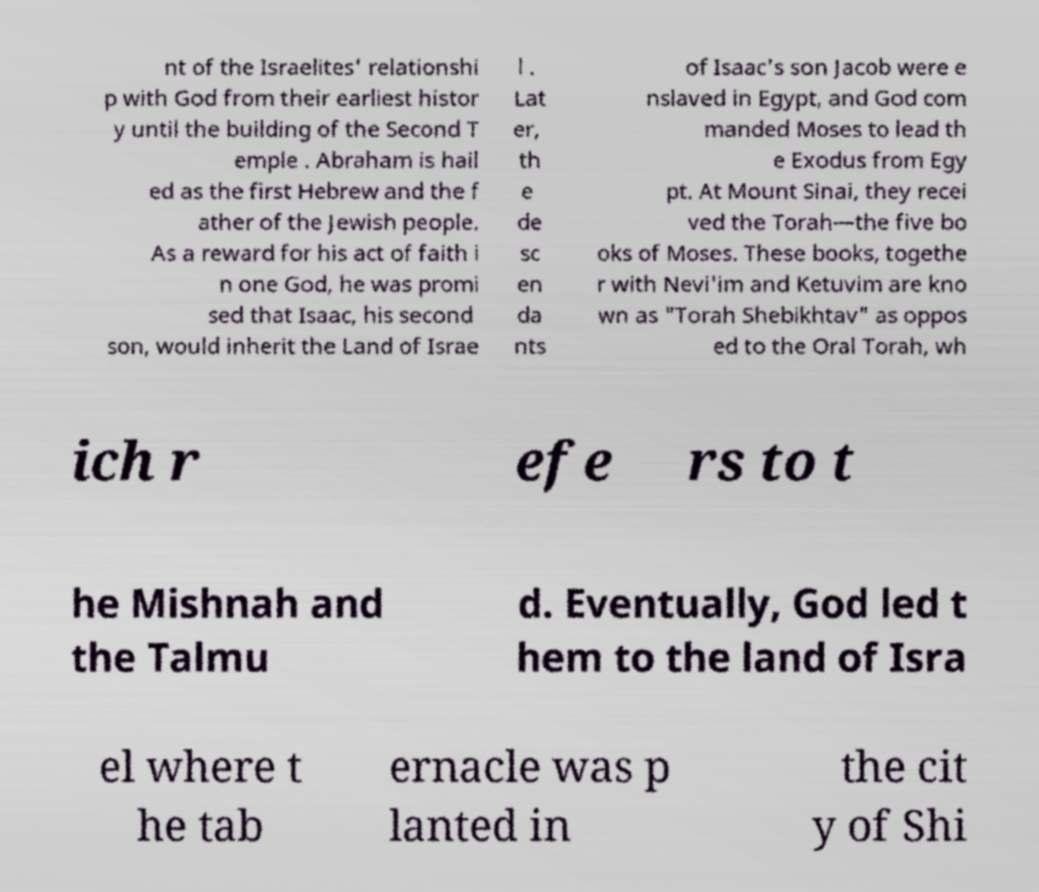There's text embedded in this image that I need extracted. Can you transcribe it verbatim? nt of the Israelites' relationshi p with God from their earliest histor y until the building of the Second T emple . Abraham is hail ed as the first Hebrew and the f ather of the Jewish people. As a reward for his act of faith i n one God, he was promi sed that Isaac, his second son, would inherit the Land of Israe l . Lat er, th e de sc en da nts of Isaac's son Jacob were e nslaved in Egypt, and God com manded Moses to lead th e Exodus from Egy pt. At Mount Sinai, they recei ved the Torah—the five bo oks of Moses. These books, togethe r with Nevi'im and Ketuvim are kno wn as "Torah Shebikhtav" as oppos ed to the Oral Torah, wh ich r efe rs to t he Mishnah and the Talmu d. Eventually, God led t hem to the land of Isra el where t he tab ernacle was p lanted in the cit y of Shi 